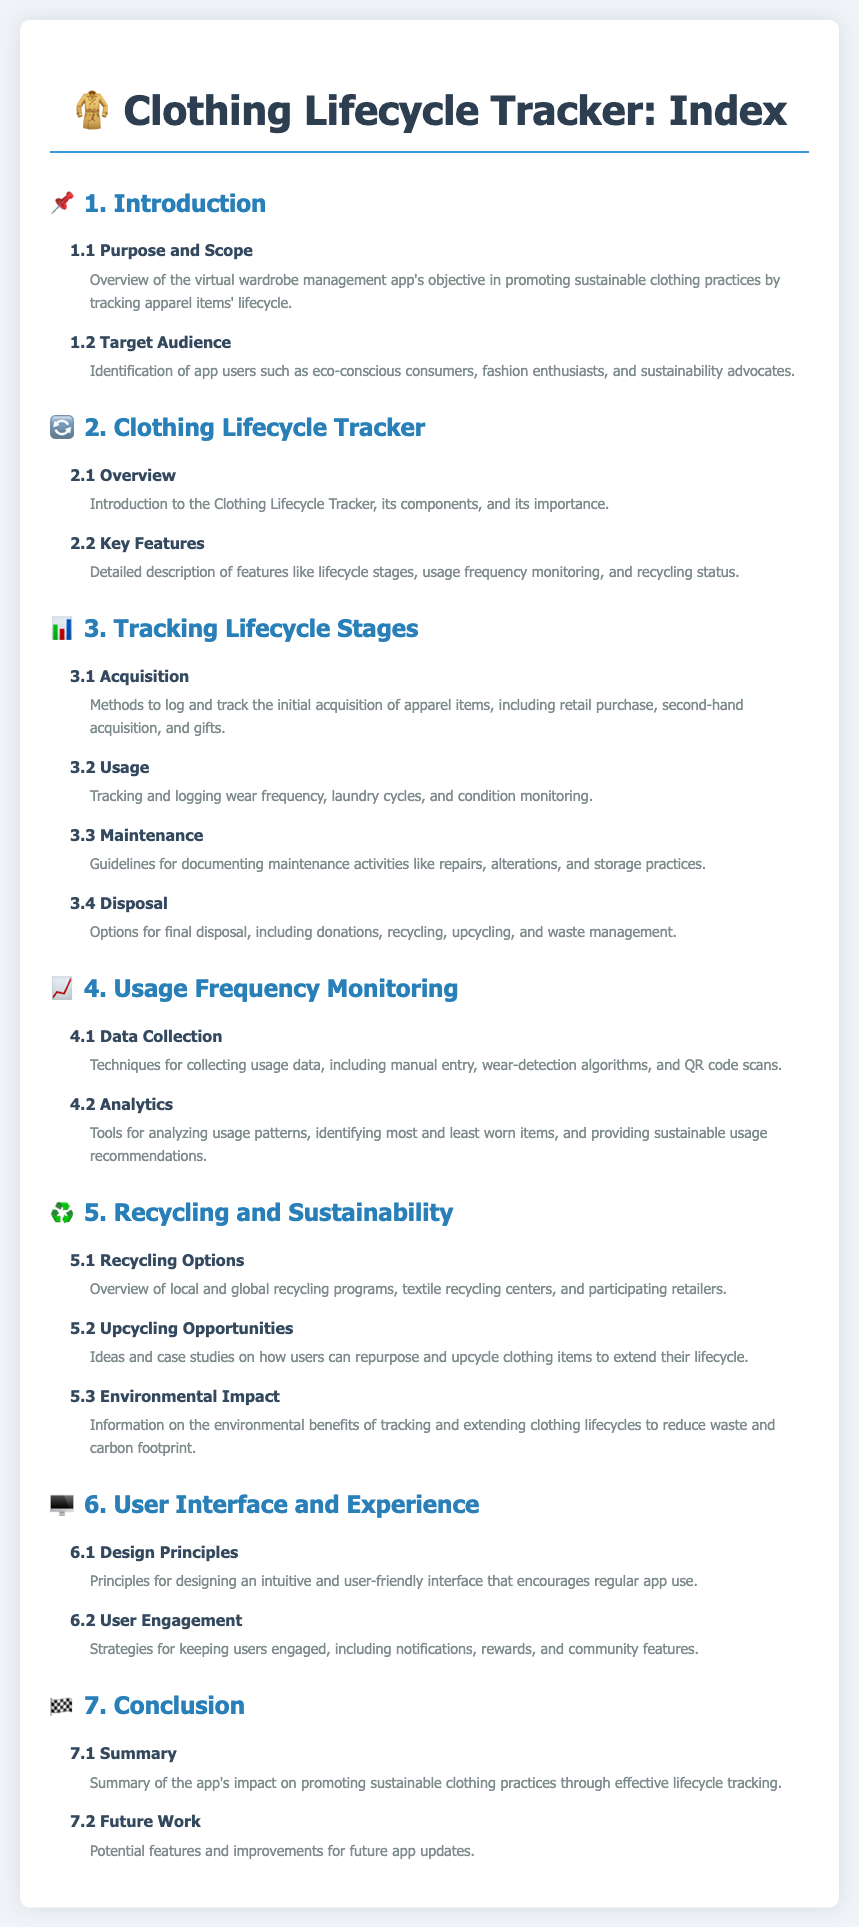What is the purpose of the app? The purpose of the app is to promote sustainable clothing practices by tracking apparel items' lifecycle.
Answer: promote sustainable clothing practices Who is the target audience of the app? The target audience includes eco-conscious consumers, fashion enthusiasts, and sustainability advocates.
Answer: eco-conscious consumers, fashion enthusiasts, sustainability advocates What is one of the key features of the Clothing Lifecycle Tracker? One of the key features is monitoring recycling status.
Answer: monitoring recycling status What are the options for final disposal? Options for final disposal include donations, recycling, upcycling, and waste management.
Answer: donations, recycling, upcycling, waste management What does the section on Data Collection discuss? The section discusses techniques for collecting usage data, including manual entry and wear-detection algorithms.
Answer: techniques for collecting usage data, including manual entry and wear-detection algorithms What environmental benefits are mentioned? The environmental benefits include reducing waste and carbon footprint.
Answer: reducing waste and carbon footprint What does the app promote in terms of clothing maintenance? The app promotes documenting maintenance activities like repairs and alterations.
Answer: documenting maintenance activities like repairs, alterations What are two user engagement strategies mentioned? Two strategies are notifications and rewards.
Answer: notifications, rewards What is the content of the 'Future Work' section? The 'Future Work' section covers potential features and improvements for future app updates.
Answer: potential features and improvements for future app updates 